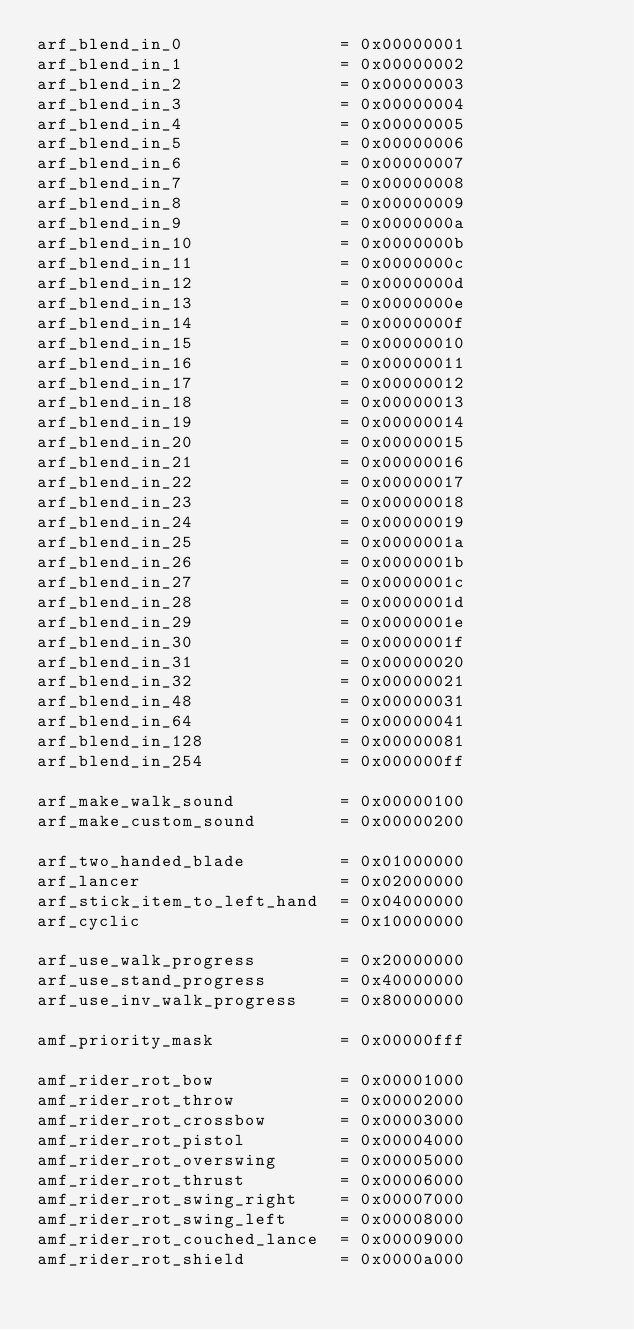<code> <loc_0><loc_0><loc_500><loc_500><_Python_>arf_blend_in_0               = 0x00000001
arf_blend_in_1               = 0x00000002
arf_blend_in_2               = 0x00000003
arf_blend_in_3               = 0x00000004
arf_blend_in_4               = 0x00000005
arf_blend_in_5               = 0x00000006
arf_blend_in_6               = 0x00000007
arf_blend_in_7               = 0x00000008
arf_blend_in_8               = 0x00000009
arf_blend_in_9               = 0x0000000a
arf_blend_in_10              = 0x0000000b
arf_blend_in_11              = 0x0000000c
arf_blend_in_12              = 0x0000000d
arf_blend_in_13              = 0x0000000e
arf_blend_in_14              = 0x0000000f
arf_blend_in_15              = 0x00000010
arf_blend_in_16              = 0x00000011
arf_blend_in_17              = 0x00000012
arf_blend_in_18              = 0x00000013
arf_blend_in_19              = 0x00000014
arf_blend_in_20              = 0x00000015
arf_blend_in_21              = 0x00000016
arf_blend_in_22              = 0x00000017
arf_blend_in_23              = 0x00000018
arf_blend_in_24              = 0x00000019
arf_blend_in_25              = 0x0000001a
arf_blend_in_26              = 0x0000001b
arf_blend_in_27              = 0x0000001c
arf_blend_in_28              = 0x0000001d
arf_blend_in_29              = 0x0000001e
arf_blend_in_30              = 0x0000001f
arf_blend_in_31              = 0x00000020
arf_blend_in_32              = 0x00000021
arf_blend_in_48              = 0x00000031
arf_blend_in_64              = 0x00000041
arf_blend_in_128             = 0x00000081
arf_blend_in_254             = 0x000000ff

arf_make_walk_sound          = 0x00000100
arf_make_custom_sound        = 0x00000200

arf_two_handed_blade         = 0x01000000
arf_lancer                   = 0x02000000
arf_stick_item_to_left_hand  = 0x04000000
arf_cyclic                   = 0x10000000

arf_use_walk_progress        = 0x20000000
arf_use_stand_progress       = 0x40000000
arf_use_inv_walk_progress    = 0x80000000

amf_priority_mask            = 0x00000fff

amf_rider_rot_bow            = 0x00001000
amf_rider_rot_throw          = 0x00002000
amf_rider_rot_crossbow       = 0x00003000
amf_rider_rot_pistol         = 0x00004000
amf_rider_rot_overswing      = 0x00005000
amf_rider_rot_thrust         = 0x00006000
amf_rider_rot_swing_right    = 0x00007000
amf_rider_rot_swing_left     = 0x00008000
amf_rider_rot_couched_lance  = 0x00009000
amf_rider_rot_shield         = 0x0000a000</code> 